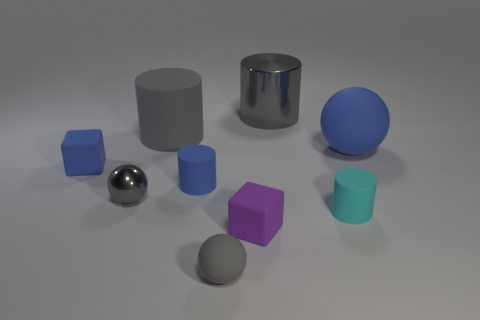Add 1 red rubber cubes. How many objects exist? 10 Subtract all cylinders. How many objects are left? 5 Add 3 cylinders. How many cylinders are left? 7 Add 6 small blue objects. How many small blue objects exist? 8 Subtract 0 red balls. How many objects are left? 9 Subtract all purple objects. Subtract all cyan matte cylinders. How many objects are left? 7 